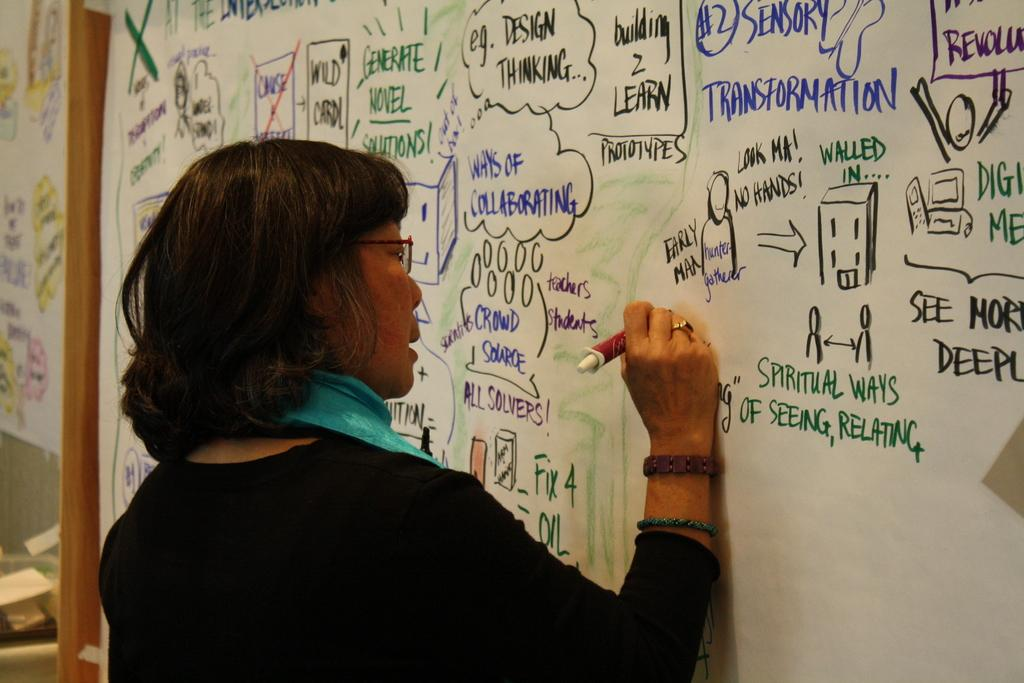<image>
Provide a brief description of the given image. Different types of text that a Woman is writing on a markerboard, example: Spiritual Ways of Seeing, Relating. 